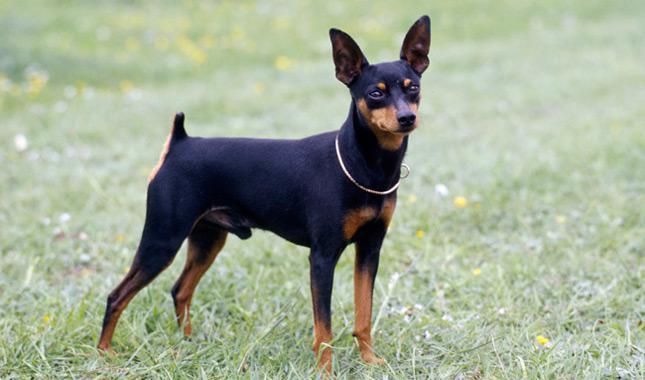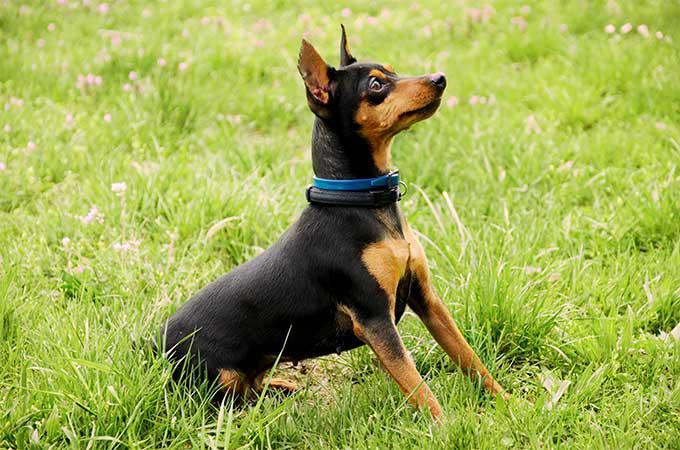The first image is the image on the left, the second image is the image on the right. For the images displayed, is the sentence "tere is a dog sitting in the grass wearing a color and has pointy ears" factually correct? Answer yes or no. Yes. The first image is the image on the left, the second image is the image on the right. For the images shown, is this caption "The left image contains at least two dogs." true? Answer yes or no. No. 